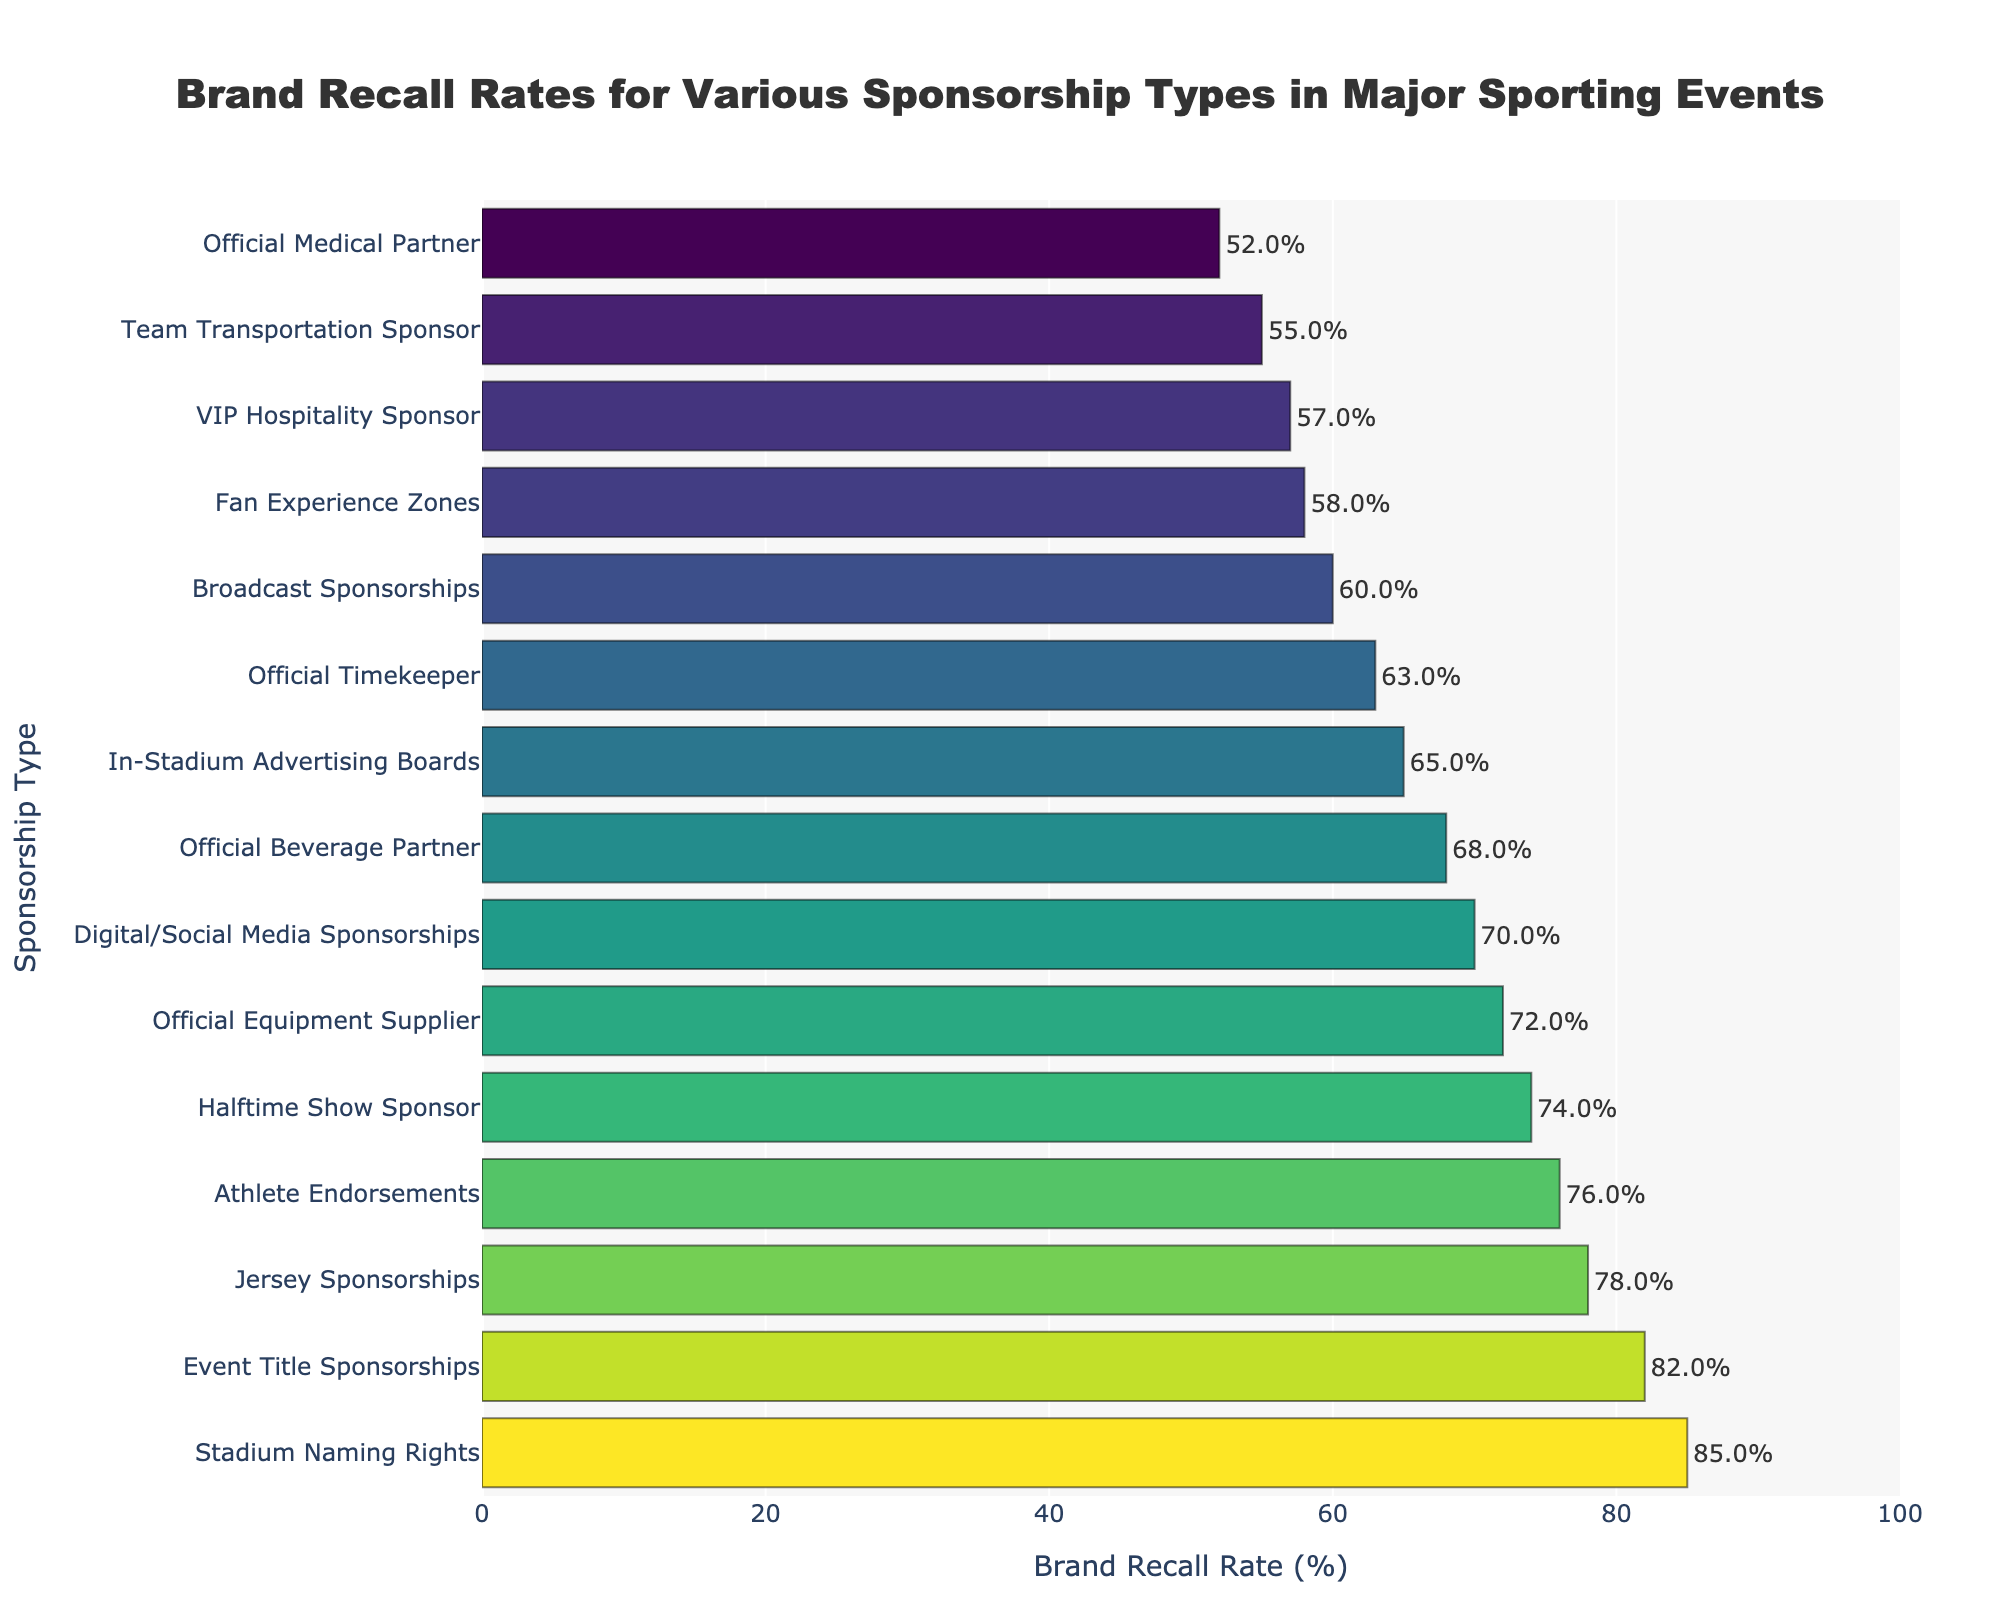What are the top three sponsorship types based on brand recall rates? By visually checking the bars, identify the three longest bars which represent the highest values. These are the sponsorship types with the highest recall rates.
Answer: Stadium Naming Rights, Event Title Sponsorships, Jersey Sponsorships How much higher is the brand recall rate for Stadium Naming Rights compared to Official Medical Partner? Refer to the lengths of the corresponding bars to find their values. The brand recall rate for Stadium Naming Rights is 85%, and for Official Medical Partner, it is 52%. Calculate the difference: 85% - 52% = 33%.
Answer: 33% What is the average brand recall rate for the top five sponsorship types? Identify the top five sponsorship types based on bar lengths (Stadium Naming Rights, Event Title Sponsorships, Jersey Sponsorships, Athlete Endorsements, Halftime Show Sponsor). Their rates are 85%, 82%, 78%, 76%, and 74%. Calculate the average: (85 + 82 + 78 + 76 + 74) / 5 = 79%.
Answer: 79% Which sponsorship type has a lower recall rate: Broadcast Sponsorships or Digital/Social Media Sponsorships? Locate the bars for both types and compare their lengths. Broadcast Sponsorships is 60%, and Digital/Social Media Sponsorships is 70%.
Answer: Broadcast Sponsorships What is the median brand recall rate across all sponsorship types? First, order all brand recall rates: 52%, 55%, 57%, 58%, 60%, 63%, 65%, 68%, 70%, 72%, 74%, 76%, 78%, 82%, 85%. The number of data points is 15, so the median is the middle value, which is the 8th value in this ordered list (68%).
Answer: 68% What is the difference in brand recall rates between In-Stadium Advertising Boards and Official Equipment Supplier? Locate the values for both types: In-Stadium Advertising Boards (65%) and Official Equipment Supplier (72%). Calculate the difference: 72% - 65% = 7%.
Answer: 7% Which sponsorship type has exactly a 57% brand recall rate? Find the bar that corresponds to a recall rate of 57%. It is the VIP Hospitality Sponsor.
Answer: VIP Hospitality Sponsor How does the recall rate for Team Transportation Sponsor compare to the overall average recall rate? Calculate the overall average recall rate from all data points: (85 + 78 + 72 + 65 + 60 + 82 + 76 + 68 + 55 + 63 + 58 + 70 + 74 + 52 + 57) / 15 = 67.27%. Then, compare it to the recall rate for Team Transportation Sponsor (55%).
Answer: Lower 